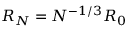<formula> <loc_0><loc_0><loc_500><loc_500>R _ { N } = N ^ { - 1 / 3 } R _ { 0 }</formula> 